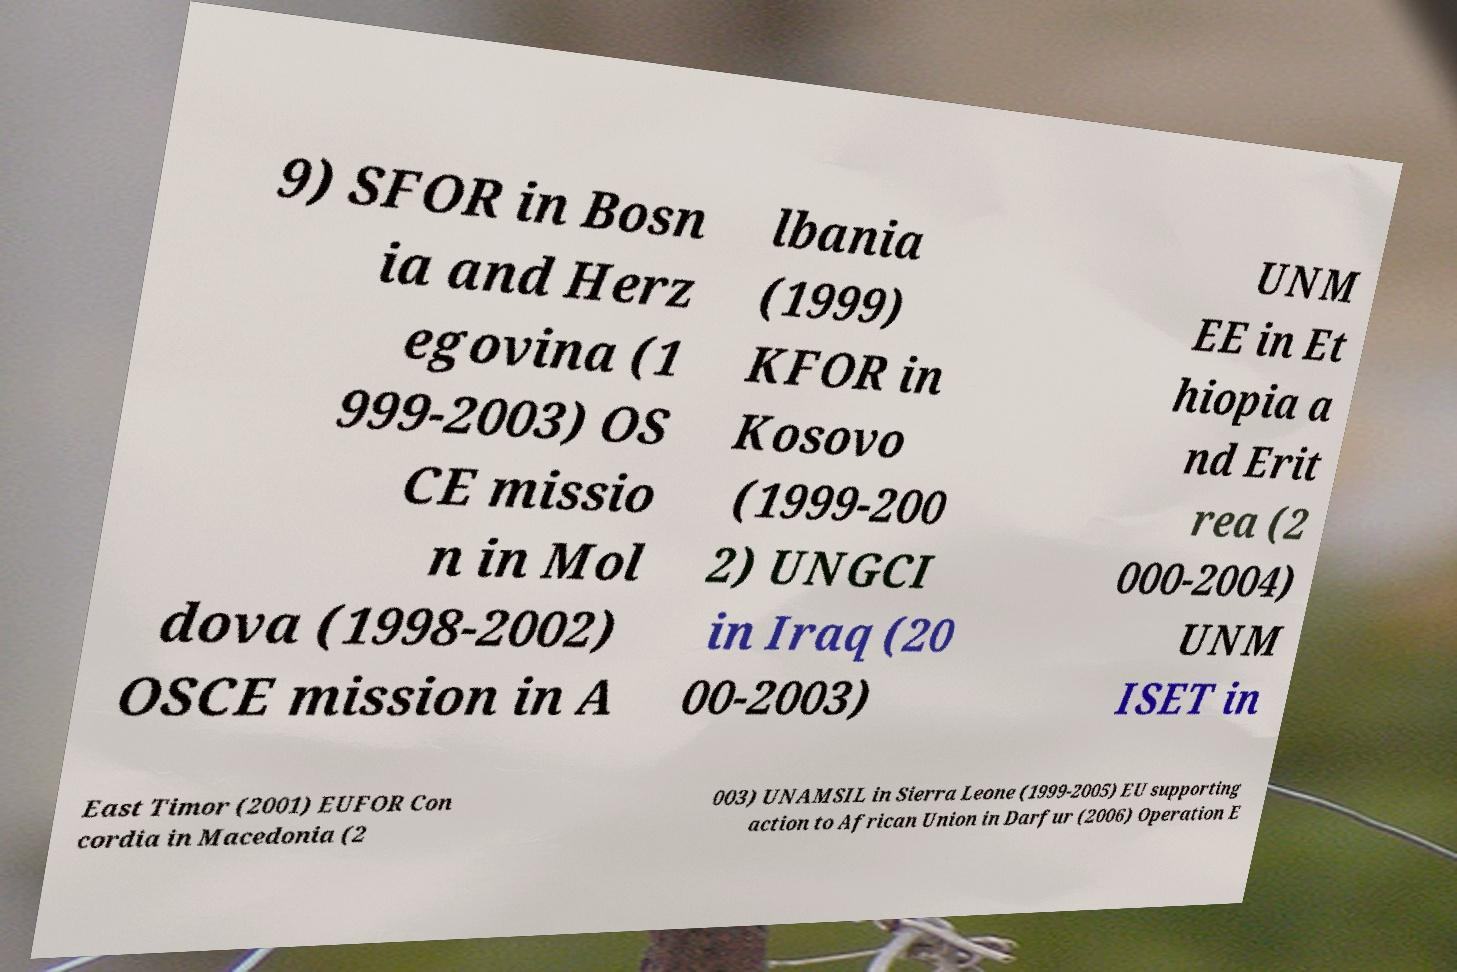For documentation purposes, I need the text within this image transcribed. Could you provide that? 9) SFOR in Bosn ia and Herz egovina (1 999-2003) OS CE missio n in Mol dova (1998-2002) OSCE mission in A lbania (1999) KFOR in Kosovo (1999-200 2) UNGCI in Iraq (20 00-2003) UNM EE in Et hiopia a nd Erit rea (2 000-2004) UNM ISET in East Timor (2001) EUFOR Con cordia in Macedonia (2 003) UNAMSIL in Sierra Leone (1999-2005) EU supporting action to African Union in Darfur (2006) Operation E 